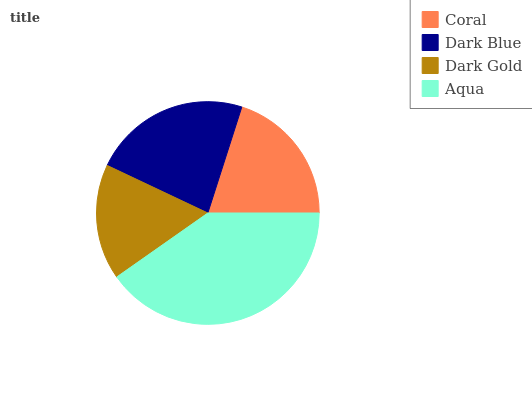Is Dark Gold the minimum?
Answer yes or no. Yes. Is Aqua the maximum?
Answer yes or no. Yes. Is Dark Blue the minimum?
Answer yes or no. No. Is Dark Blue the maximum?
Answer yes or no. No. Is Dark Blue greater than Coral?
Answer yes or no. Yes. Is Coral less than Dark Blue?
Answer yes or no. Yes. Is Coral greater than Dark Blue?
Answer yes or no. No. Is Dark Blue less than Coral?
Answer yes or no. No. Is Dark Blue the high median?
Answer yes or no. Yes. Is Coral the low median?
Answer yes or no. Yes. Is Coral the high median?
Answer yes or no. No. Is Dark Gold the low median?
Answer yes or no. No. 